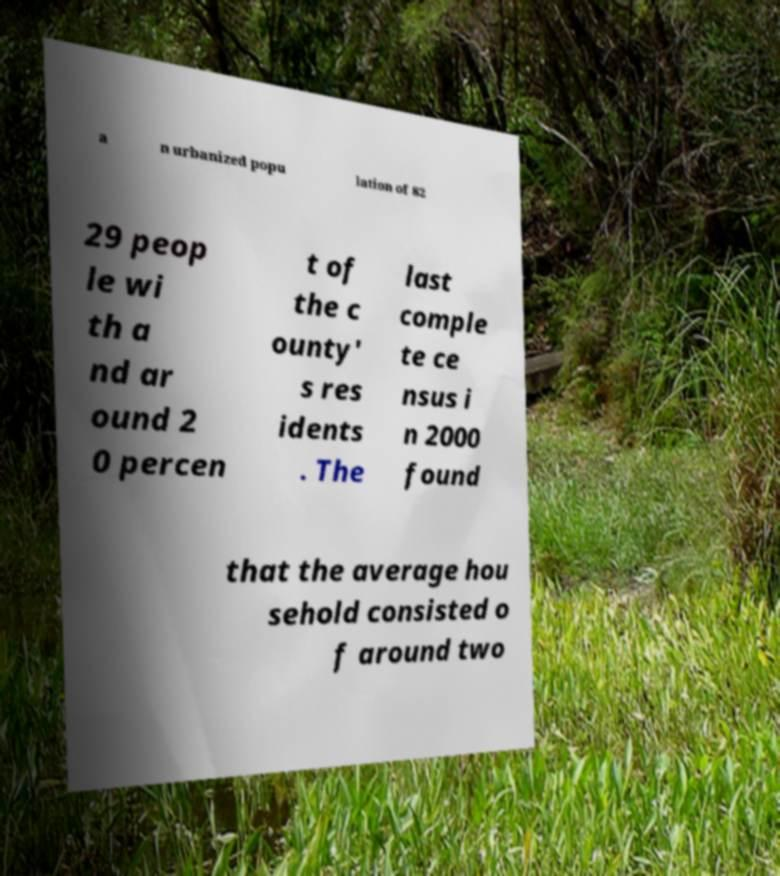Could you assist in decoding the text presented in this image and type it out clearly? a n urbanized popu lation of 82 29 peop le wi th a nd ar ound 2 0 percen t of the c ounty' s res idents . The last comple te ce nsus i n 2000 found that the average hou sehold consisted o f around two 